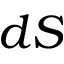<formula> <loc_0><loc_0><loc_500><loc_500>d S</formula> 